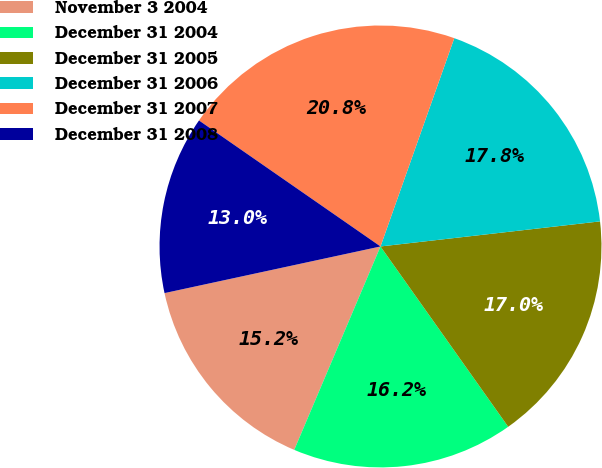<chart> <loc_0><loc_0><loc_500><loc_500><pie_chart><fcel>November 3 2004<fcel>December 31 2004<fcel>December 31 2005<fcel>December 31 2006<fcel>December 31 2007<fcel>December 31 2008<nl><fcel>15.23%<fcel>16.19%<fcel>17.0%<fcel>17.77%<fcel>20.76%<fcel>13.04%<nl></chart> 